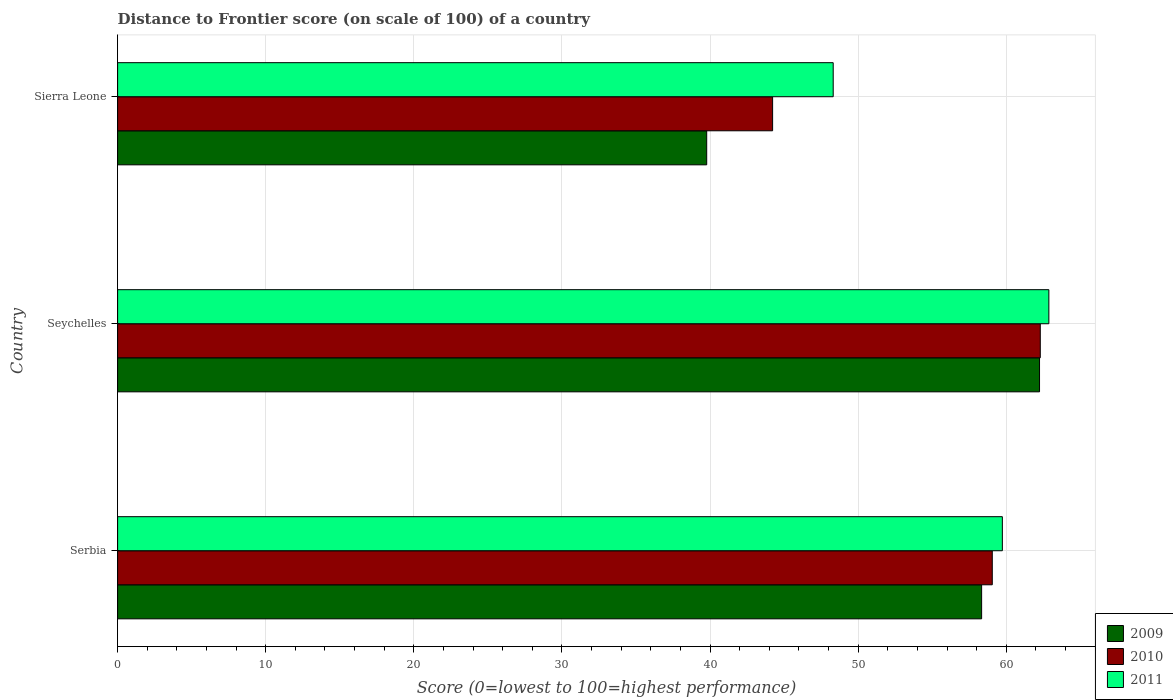How many different coloured bars are there?
Ensure brevity in your answer.  3. Are the number of bars on each tick of the Y-axis equal?
Give a very brief answer. Yes. How many bars are there on the 1st tick from the top?
Your response must be concise. 3. What is the label of the 3rd group of bars from the top?
Ensure brevity in your answer.  Serbia. In how many cases, is the number of bars for a given country not equal to the number of legend labels?
Provide a short and direct response. 0. What is the distance to frontier score of in 2009 in Serbia?
Offer a terse response. 58.33. Across all countries, what is the maximum distance to frontier score of in 2009?
Offer a terse response. 62.24. Across all countries, what is the minimum distance to frontier score of in 2010?
Keep it short and to the point. 44.22. In which country was the distance to frontier score of in 2011 maximum?
Your answer should be compact. Seychelles. In which country was the distance to frontier score of in 2010 minimum?
Keep it short and to the point. Sierra Leone. What is the total distance to frontier score of in 2010 in the graph?
Keep it short and to the point. 165.56. What is the difference between the distance to frontier score of in 2010 in Seychelles and that in Sierra Leone?
Offer a very short reply. 18.07. What is the difference between the distance to frontier score of in 2010 in Sierra Leone and the distance to frontier score of in 2011 in Serbia?
Offer a terse response. -15.51. What is the average distance to frontier score of in 2010 per country?
Your response must be concise. 55.19. What is the difference between the distance to frontier score of in 2009 and distance to frontier score of in 2011 in Sierra Leone?
Ensure brevity in your answer.  -8.54. What is the ratio of the distance to frontier score of in 2010 in Serbia to that in Seychelles?
Keep it short and to the point. 0.95. Is the distance to frontier score of in 2011 in Seychelles less than that in Sierra Leone?
Offer a very short reply. No. What is the difference between the highest and the second highest distance to frontier score of in 2011?
Provide a succinct answer. 3.14. What is the difference between the highest and the lowest distance to frontier score of in 2011?
Your answer should be compact. 14.56. What does the 2nd bar from the top in Serbia represents?
Give a very brief answer. 2010. Is it the case that in every country, the sum of the distance to frontier score of in 2010 and distance to frontier score of in 2011 is greater than the distance to frontier score of in 2009?
Give a very brief answer. Yes. How many bars are there?
Your response must be concise. 9. Are all the bars in the graph horizontal?
Give a very brief answer. Yes. How many countries are there in the graph?
Provide a short and direct response. 3. What is the difference between two consecutive major ticks on the X-axis?
Provide a succinct answer. 10. Are the values on the major ticks of X-axis written in scientific E-notation?
Make the answer very short. No. Does the graph contain grids?
Your response must be concise. Yes. Where does the legend appear in the graph?
Your answer should be very brief. Bottom right. What is the title of the graph?
Make the answer very short. Distance to Frontier score (on scale of 100) of a country. What is the label or title of the X-axis?
Your answer should be very brief. Score (0=lowest to 100=highest performance). What is the Score (0=lowest to 100=highest performance) of 2009 in Serbia?
Give a very brief answer. 58.33. What is the Score (0=lowest to 100=highest performance) in 2010 in Serbia?
Keep it short and to the point. 59.05. What is the Score (0=lowest to 100=highest performance) of 2011 in Serbia?
Your response must be concise. 59.73. What is the Score (0=lowest to 100=highest performance) in 2009 in Seychelles?
Offer a very short reply. 62.24. What is the Score (0=lowest to 100=highest performance) of 2010 in Seychelles?
Ensure brevity in your answer.  62.29. What is the Score (0=lowest to 100=highest performance) in 2011 in Seychelles?
Keep it short and to the point. 62.87. What is the Score (0=lowest to 100=highest performance) of 2009 in Sierra Leone?
Provide a short and direct response. 39.77. What is the Score (0=lowest to 100=highest performance) of 2010 in Sierra Leone?
Offer a very short reply. 44.22. What is the Score (0=lowest to 100=highest performance) of 2011 in Sierra Leone?
Your response must be concise. 48.31. Across all countries, what is the maximum Score (0=lowest to 100=highest performance) in 2009?
Keep it short and to the point. 62.24. Across all countries, what is the maximum Score (0=lowest to 100=highest performance) of 2010?
Keep it short and to the point. 62.29. Across all countries, what is the maximum Score (0=lowest to 100=highest performance) of 2011?
Offer a very short reply. 62.87. Across all countries, what is the minimum Score (0=lowest to 100=highest performance) of 2009?
Offer a terse response. 39.77. Across all countries, what is the minimum Score (0=lowest to 100=highest performance) in 2010?
Provide a succinct answer. 44.22. Across all countries, what is the minimum Score (0=lowest to 100=highest performance) of 2011?
Ensure brevity in your answer.  48.31. What is the total Score (0=lowest to 100=highest performance) of 2009 in the graph?
Provide a succinct answer. 160.34. What is the total Score (0=lowest to 100=highest performance) of 2010 in the graph?
Your answer should be compact. 165.56. What is the total Score (0=lowest to 100=highest performance) in 2011 in the graph?
Make the answer very short. 170.91. What is the difference between the Score (0=lowest to 100=highest performance) of 2009 in Serbia and that in Seychelles?
Provide a short and direct response. -3.91. What is the difference between the Score (0=lowest to 100=highest performance) in 2010 in Serbia and that in Seychelles?
Make the answer very short. -3.24. What is the difference between the Score (0=lowest to 100=highest performance) in 2011 in Serbia and that in Seychelles?
Make the answer very short. -3.14. What is the difference between the Score (0=lowest to 100=highest performance) of 2009 in Serbia and that in Sierra Leone?
Your response must be concise. 18.56. What is the difference between the Score (0=lowest to 100=highest performance) of 2010 in Serbia and that in Sierra Leone?
Offer a very short reply. 14.83. What is the difference between the Score (0=lowest to 100=highest performance) in 2011 in Serbia and that in Sierra Leone?
Offer a very short reply. 11.42. What is the difference between the Score (0=lowest to 100=highest performance) of 2009 in Seychelles and that in Sierra Leone?
Make the answer very short. 22.47. What is the difference between the Score (0=lowest to 100=highest performance) in 2010 in Seychelles and that in Sierra Leone?
Ensure brevity in your answer.  18.07. What is the difference between the Score (0=lowest to 100=highest performance) of 2011 in Seychelles and that in Sierra Leone?
Give a very brief answer. 14.56. What is the difference between the Score (0=lowest to 100=highest performance) of 2009 in Serbia and the Score (0=lowest to 100=highest performance) of 2010 in Seychelles?
Ensure brevity in your answer.  -3.96. What is the difference between the Score (0=lowest to 100=highest performance) of 2009 in Serbia and the Score (0=lowest to 100=highest performance) of 2011 in Seychelles?
Keep it short and to the point. -4.54. What is the difference between the Score (0=lowest to 100=highest performance) in 2010 in Serbia and the Score (0=lowest to 100=highest performance) in 2011 in Seychelles?
Offer a terse response. -3.82. What is the difference between the Score (0=lowest to 100=highest performance) in 2009 in Serbia and the Score (0=lowest to 100=highest performance) in 2010 in Sierra Leone?
Your answer should be compact. 14.11. What is the difference between the Score (0=lowest to 100=highest performance) in 2009 in Serbia and the Score (0=lowest to 100=highest performance) in 2011 in Sierra Leone?
Your answer should be very brief. 10.02. What is the difference between the Score (0=lowest to 100=highest performance) in 2010 in Serbia and the Score (0=lowest to 100=highest performance) in 2011 in Sierra Leone?
Make the answer very short. 10.74. What is the difference between the Score (0=lowest to 100=highest performance) in 2009 in Seychelles and the Score (0=lowest to 100=highest performance) in 2010 in Sierra Leone?
Your answer should be very brief. 18.02. What is the difference between the Score (0=lowest to 100=highest performance) in 2009 in Seychelles and the Score (0=lowest to 100=highest performance) in 2011 in Sierra Leone?
Your answer should be compact. 13.93. What is the difference between the Score (0=lowest to 100=highest performance) of 2010 in Seychelles and the Score (0=lowest to 100=highest performance) of 2011 in Sierra Leone?
Provide a short and direct response. 13.98. What is the average Score (0=lowest to 100=highest performance) in 2009 per country?
Offer a very short reply. 53.45. What is the average Score (0=lowest to 100=highest performance) of 2010 per country?
Provide a succinct answer. 55.19. What is the average Score (0=lowest to 100=highest performance) in 2011 per country?
Your response must be concise. 56.97. What is the difference between the Score (0=lowest to 100=highest performance) of 2009 and Score (0=lowest to 100=highest performance) of 2010 in Serbia?
Make the answer very short. -0.72. What is the difference between the Score (0=lowest to 100=highest performance) in 2010 and Score (0=lowest to 100=highest performance) in 2011 in Serbia?
Offer a terse response. -0.68. What is the difference between the Score (0=lowest to 100=highest performance) in 2009 and Score (0=lowest to 100=highest performance) in 2011 in Seychelles?
Provide a short and direct response. -0.63. What is the difference between the Score (0=lowest to 100=highest performance) in 2010 and Score (0=lowest to 100=highest performance) in 2011 in Seychelles?
Give a very brief answer. -0.58. What is the difference between the Score (0=lowest to 100=highest performance) in 2009 and Score (0=lowest to 100=highest performance) in 2010 in Sierra Leone?
Your answer should be compact. -4.45. What is the difference between the Score (0=lowest to 100=highest performance) in 2009 and Score (0=lowest to 100=highest performance) in 2011 in Sierra Leone?
Offer a very short reply. -8.54. What is the difference between the Score (0=lowest to 100=highest performance) in 2010 and Score (0=lowest to 100=highest performance) in 2011 in Sierra Leone?
Make the answer very short. -4.09. What is the ratio of the Score (0=lowest to 100=highest performance) in 2009 in Serbia to that in Seychelles?
Your answer should be compact. 0.94. What is the ratio of the Score (0=lowest to 100=highest performance) of 2010 in Serbia to that in Seychelles?
Keep it short and to the point. 0.95. What is the ratio of the Score (0=lowest to 100=highest performance) in 2011 in Serbia to that in Seychelles?
Ensure brevity in your answer.  0.95. What is the ratio of the Score (0=lowest to 100=highest performance) of 2009 in Serbia to that in Sierra Leone?
Offer a very short reply. 1.47. What is the ratio of the Score (0=lowest to 100=highest performance) in 2010 in Serbia to that in Sierra Leone?
Offer a terse response. 1.34. What is the ratio of the Score (0=lowest to 100=highest performance) in 2011 in Serbia to that in Sierra Leone?
Provide a short and direct response. 1.24. What is the ratio of the Score (0=lowest to 100=highest performance) in 2009 in Seychelles to that in Sierra Leone?
Make the answer very short. 1.56. What is the ratio of the Score (0=lowest to 100=highest performance) of 2010 in Seychelles to that in Sierra Leone?
Your answer should be very brief. 1.41. What is the ratio of the Score (0=lowest to 100=highest performance) of 2011 in Seychelles to that in Sierra Leone?
Your response must be concise. 1.3. What is the difference between the highest and the second highest Score (0=lowest to 100=highest performance) of 2009?
Offer a terse response. 3.91. What is the difference between the highest and the second highest Score (0=lowest to 100=highest performance) in 2010?
Your answer should be very brief. 3.24. What is the difference between the highest and the second highest Score (0=lowest to 100=highest performance) in 2011?
Give a very brief answer. 3.14. What is the difference between the highest and the lowest Score (0=lowest to 100=highest performance) in 2009?
Offer a very short reply. 22.47. What is the difference between the highest and the lowest Score (0=lowest to 100=highest performance) of 2010?
Your response must be concise. 18.07. What is the difference between the highest and the lowest Score (0=lowest to 100=highest performance) in 2011?
Your answer should be compact. 14.56. 